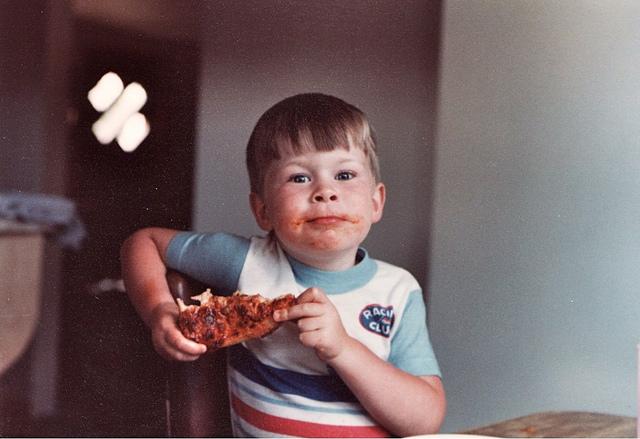What is the boy eating?
Write a very short answer. Pizza. Is anyone else in the photo?
Be succinct. No. What color is his shirt?
Concise answer only. White, blue and red. Is his face messy?
Concise answer only. Yes. 